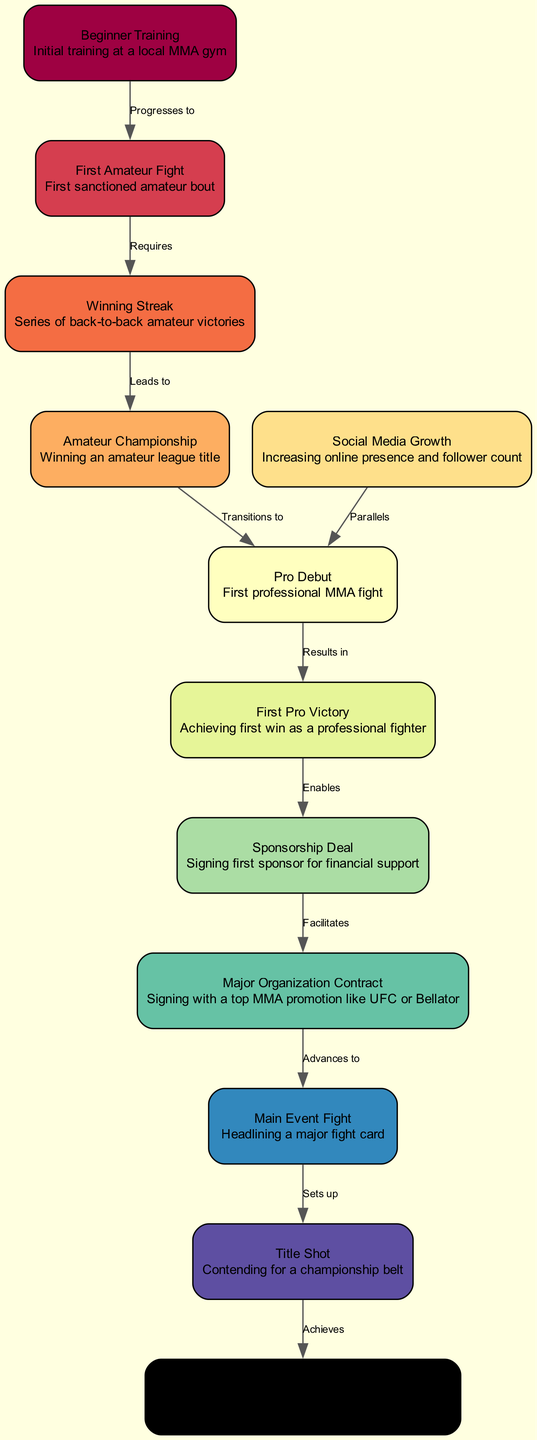What is the first milestone in the diagram? The first node in the diagram is "Beginner Training," which represents the initial training phase for a mixed martial arts competitor.
Answer: Beginner Training How many nodes are there in the diagram? By counting the nodes listed in the data, there are a total of 12 nodes, each representing a different milestone in the MMA career progression.
Answer: 12 What milestone follows "Pro Debut"? Following the "Pro Debut" node, the next milestone is "First Pro Victory," which represents achieving the first win as a professional fighter.
Answer: First Pro Victory What does "Winning Streak" lead to? According to the diagram, the "Winning Streak" leads to "Amateur Championship," signifying a series of victories culminating in winning an amateur title.
Answer: Amateur Championship Which milestone is described as achieving a championship belt in a major organization? The node described as winning a championship belt in a major organization is "World Champion," which signifies the pinnacle achievement in a fighter's career.
Answer: World Champion What relationship exists between "Social Media Growth" and "Pro Debut"? "Social Media Growth" parallels "Pro Debut," indicating that increasing online presence occurs alongside the fighter's transition into professional bouts.
Answer: Parallels Which milestone enables the signing of a sponsorship deal? The milestone that enables the signing of a sponsorship deal is "First Pro Victory," as achieving a professional win can attract sponsors looking for promising fighters.
Answer: First Pro Victory What does progressing from "Amateur Championship" to "Pro Debut" signify? Progressing from "Amateur Championship" to "Pro Debut" signifies the transition from amateur status to entering the professional fighting circuit after achieving recognition in amateur competitions.
Answer: Transitions to How many edges are there in the diagram? By counting the edges listed, there are a total of 11 edges, each representing the relationships between different milestones in the career progression.
Answer: 11 